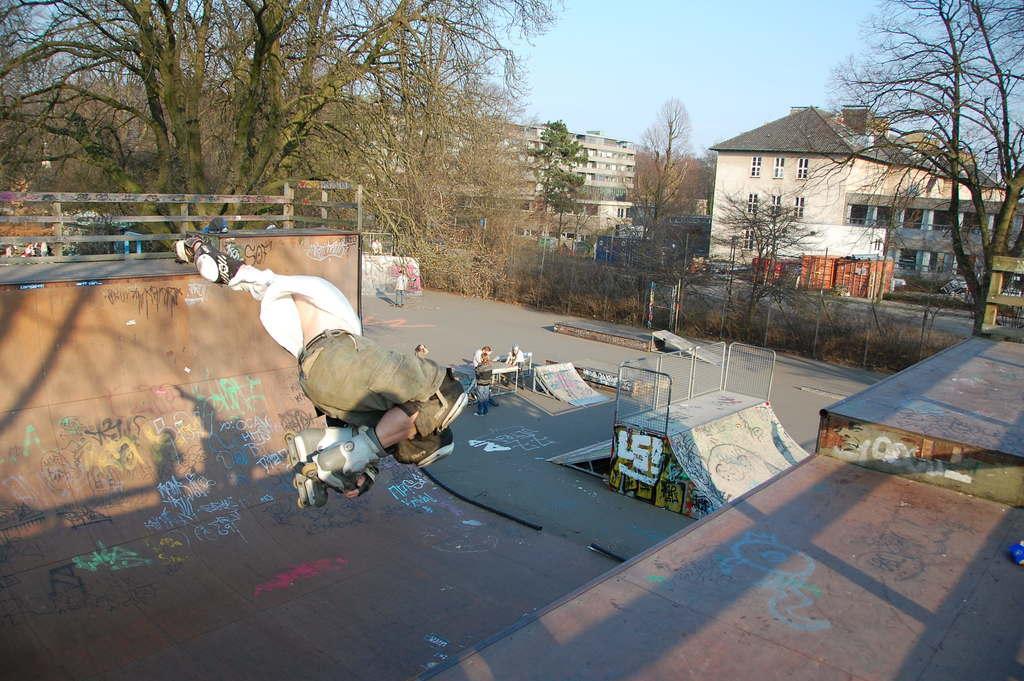Describe this image in one or two sentences. A person is in the air and wore skating shoes. Under the person we can see a skating ramp. Background portion of the image we can see trees, buildings, fence, mesh, slopes, skate ramp, table, railing, people, sky and things.  